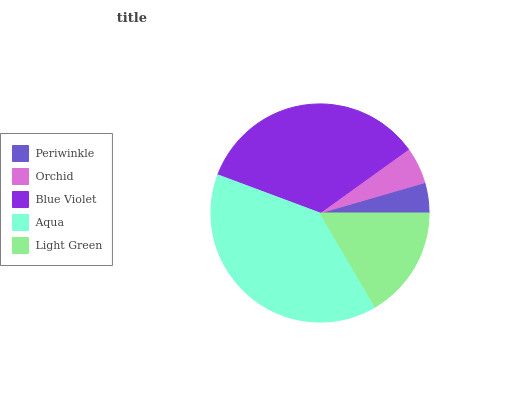Is Periwinkle the minimum?
Answer yes or no. Yes. Is Aqua the maximum?
Answer yes or no. Yes. Is Orchid the minimum?
Answer yes or no. No. Is Orchid the maximum?
Answer yes or no. No. Is Orchid greater than Periwinkle?
Answer yes or no. Yes. Is Periwinkle less than Orchid?
Answer yes or no. Yes. Is Periwinkle greater than Orchid?
Answer yes or no. No. Is Orchid less than Periwinkle?
Answer yes or no. No. Is Light Green the high median?
Answer yes or no. Yes. Is Light Green the low median?
Answer yes or no. Yes. Is Orchid the high median?
Answer yes or no. No. Is Blue Violet the low median?
Answer yes or no. No. 